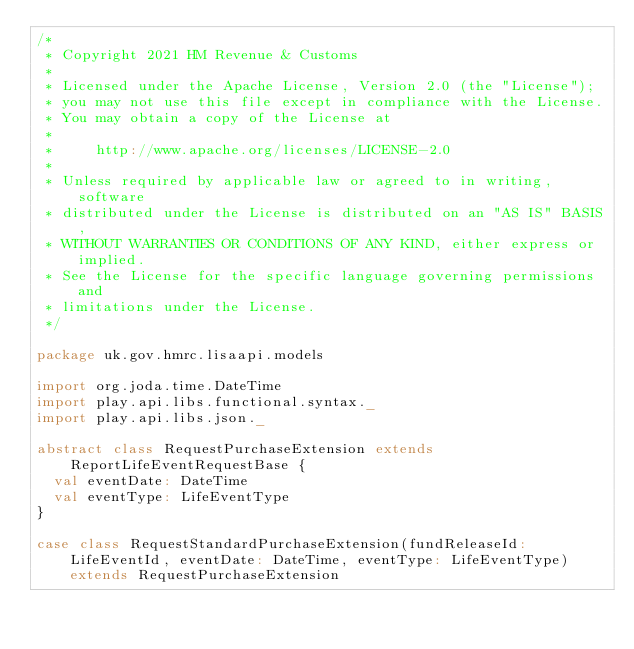Convert code to text. <code><loc_0><loc_0><loc_500><loc_500><_Scala_>/*
 * Copyright 2021 HM Revenue & Customs
 *
 * Licensed under the Apache License, Version 2.0 (the "License");
 * you may not use this file except in compliance with the License.
 * You may obtain a copy of the License at
 *
 *     http://www.apache.org/licenses/LICENSE-2.0
 *
 * Unless required by applicable law or agreed to in writing, software
 * distributed under the License is distributed on an "AS IS" BASIS,
 * WITHOUT WARRANTIES OR CONDITIONS OF ANY KIND, either express or implied.
 * See the License for the specific language governing permissions and
 * limitations under the License.
 */

package uk.gov.hmrc.lisaapi.models

import org.joda.time.DateTime
import play.api.libs.functional.syntax._
import play.api.libs.json._

abstract class RequestPurchaseExtension extends ReportLifeEventRequestBase {
  val eventDate: DateTime
  val eventType: LifeEventType
}

case class RequestStandardPurchaseExtension(fundReleaseId: LifeEventId, eventDate: DateTime, eventType: LifeEventType) extends RequestPurchaseExtension</code> 